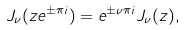<formula> <loc_0><loc_0><loc_500><loc_500>J _ { \nu } ( z e ^ { \pm \pi i } ) = e ^ { \pm \nu \pi i } J _ { \nu } ( z ) ,</formula> 